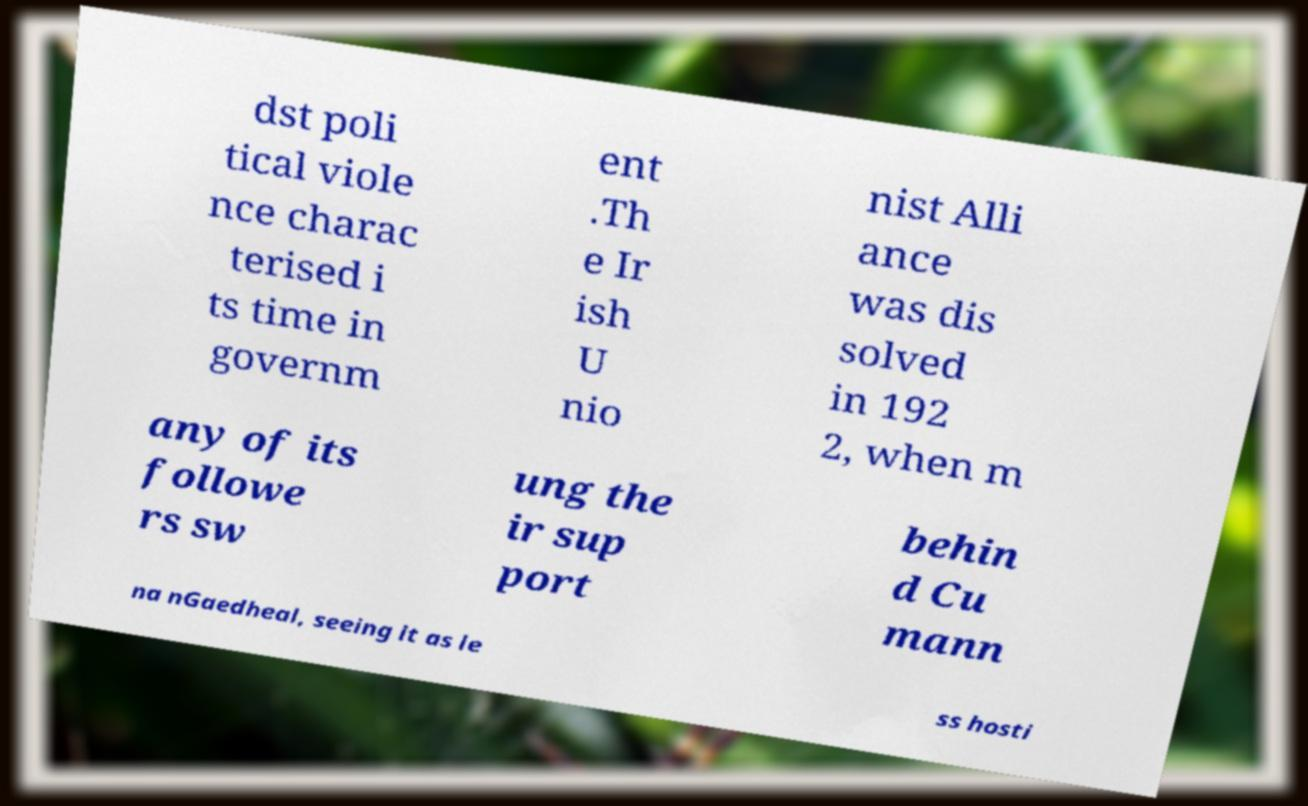There's text embedded in this image that I need extracted. Can you transcribe it verbatim? dst poli tical viole nce charac terised i ts time in governm ent .Th e Ir ish U nio nist Alli ance was dis solved in 192 2, when m any of its followe rs sw ung the ir sup port behin d Cu mann na nGaedheal, seeing it as le ss hosti 